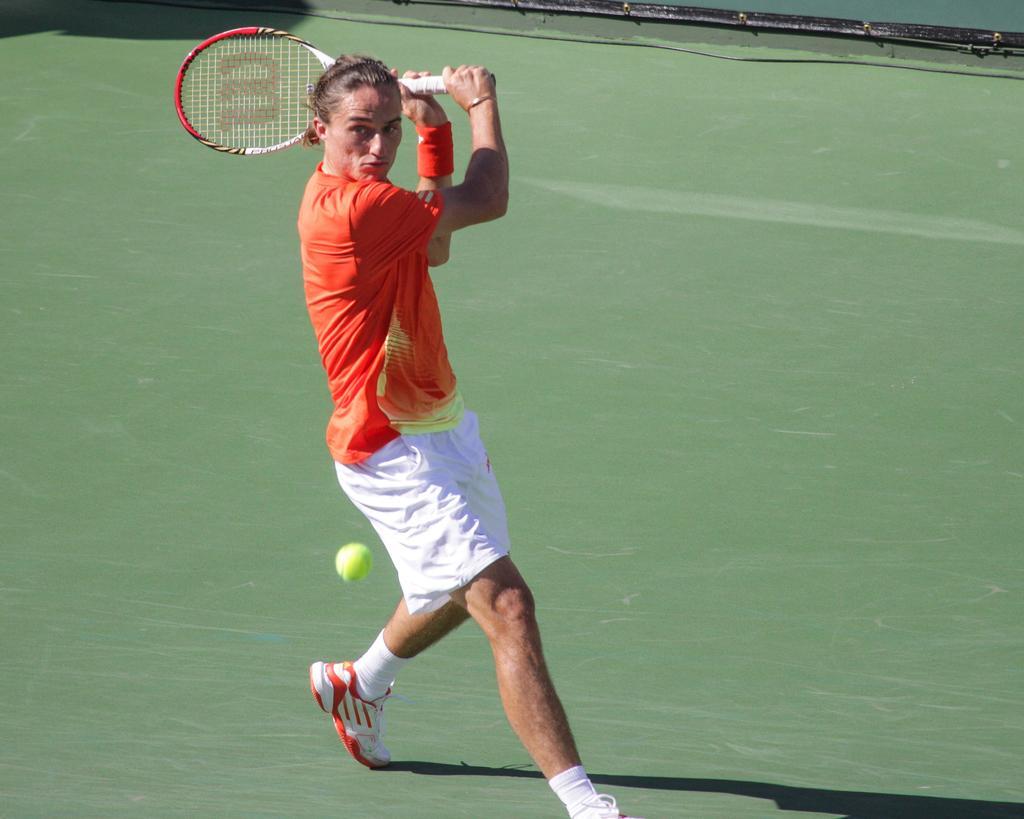Could you give a brief overview of what you see in this image? In the person we can see a person running and hitting a tennis ball with a tennis bat and the person is wearing an orange T-shirt and white shoe and socks. 